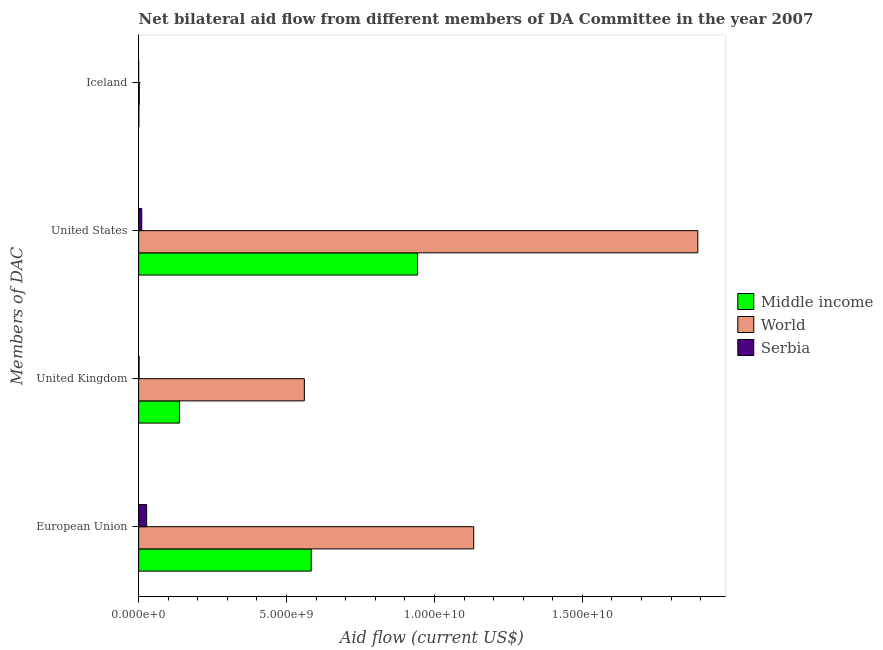How many different coloured bars are there?
Give a very brief answer. 3. How many groups of bars are there?
Give a very brief answer. 4. Are the number of bars per tick equal to the number of legend labels?
Your answer should be compact. Yes. Are the number of bars on each tick of the Y-axis equal?
Make the answer very short. Yes. How many bars are there on the 2nd tick from the top?
Offer a very short reply. 3. How many bars are there on the 4th tick from the bottom?
Provide a succinct answer. 3. What is the amount of aid given by iceland in Middle income?
Your answer should be very brief. 8.06e+06. Across all countries, what is the maximum amount of aid given by eu?
Make the answer very short. 1.13e+1. Across all countries, what is the minimum amount of aid given by us?
Your answer should be compact. 1.05e+08. In which country was the amount of aid given by us minimum?
Make the answer very short. Serbia. What is the total amount of aid given by iceland in the graph?
Give a very brief answer. 3.13e+07. What is the difference between the amount of aid given by us in World and that in Serbia?
Give a very brief answer. 1.88e+1. What is the difference between the amount of aid given by iceland in Middle income and the amount of aid given by uk in World?
Provide a succinct answer. -5.59e+09. What is the average amount of aid given by iceland per country?
Provide a short and direct response. 1.04e+07. What is the difference between the amount of aid given by us and amount of aid given by eu in Serbia?
Ensure brevity in your answer.  -1.66e+08. What is the ratio of the amount of aid given by us in Middle income to that in World?
Offer a terse response. 0.5. Is the amount of aid given by uk in World less than that in Serbia?
Give a very brief answer. No. Is the difference between the amount of aid given by us in World and Serbia greater than the difference between the amount of aid given by iceland in World and Serbia?
Your response must be concise. Yes. What is the difference between the highest and the second highest amount of aid given by eu?
Keep it short and to the point. 5.49e+09. What is the difference between the highest and the lowest amount of aid given by us?
Your response must be concise. 1.88e+1. What does the 1st bar from the top in United Kingdom represents?
Your answer should be very brief. Serbia. What does the 3rd bar from the bottom in European Union represents?
Provide a short and direct response. Serbia. How many bars are there?
Your response must be concise. 12. Are all the bars in the graph horizontal?
Make the answer very short. Yes. How many countries are there in the graph?
Keep it short and to the point. 3. Are the values on the major ticks of X-axis written in scientific E-notation?
Provide a succinct answer. Yes. How many legend labels are there?
Provide a succinct answer. 3. How are the legend labels stacked?
Keep it short and to the point. Vertical. What is the title of the graph?
Your answer should be very brief. Net bilateral aid flow from different members of DA Committee in the year 2007. What is the label or title of the Y-axis?
Ensure brevity in your answer.  Members of DAC. What is the Aid flow (current US$) of Middle income in European Union?
Ensure brevity in your answer.  5.83e+09. What is the Aid flow (current US$) in World in European Union?
Offer a terse response. 1.13e+1. What is the Aid flow (current US$) in Serbia in European Union?
Ensure brevity in your answer.  2.71e+08. What is the Aid flow (current US$) of Middle income in United Kingdom?
Offer a very short reply. 1.38e+09. What is the Aid flow (current US$) of World in United Kingdom?
Ensure brevity in your answer.  5.60e+09. What is the Aid flow (current US$) of Serbia in United Kingdom?
Give a very brief answer. 1.55e+07. What is the Aid flow (current US$) in Middle income in United States?
Your answer should be compact. 9.43e+09. What is the Aid flow (current US$) in World in United States?
Provide a succinct answer. 1.89e+1. What is the Aid flow (current US$) in Serbia in United States?
Offer a terse response. 1.05e+08. What is the Aid flow (current US$) of Middle income in Iceland?
Provide a short and direct response. 8.06e+06. What is the Aid flow (current US$) in World in Iceland?
Offer a very short reply. 2.30e+07. Across all Members of DAC, what is the maximum Aid flow (current US$) of Middle income?
Keep it short and to the point. 9.43e+09. Across all Members of DAC, what is the maximum Aid flow (current US$) of World?
Offer a terse response. 1.89e+1. Across all Members of DAC, what is the maximum Aid flow (current US$) in Serbia?
Provide a short and direct response. 2.71e+08. Across all Members of DAC, what is the minimum Aid flow (current US$) of Middle income?
Make the answer very short. 8.06e+06. Across all Members of DAC, what is the minimum Aid flow (current US$) in World?
Provide a short and direct response. 2.30e+07. Across all Members of DAC, what is the minimum Aid flow (current US$) in Serbia?
Your response must be concise. 2.20e+05. What is the total Aid flow (current US$) in Middle income in the graph?
Your answer should be compact. 1.66e+1. What is the total Aid flow (current US$) in World in the graph?
Ensure brevity in your answer.  3.59e+1. What is the total Aid flow (current US$) of Serbia in the graph?
Your answer should be very brief. 3.92e+08. What is the difference between the Aid flow (current US$) in Middle income in European Union and that in United Kingdom?
Give a very brief answer. 4.45e+09. What is the difference between the Aid flow (current US$) in World in European Union and that in United Kingdom?
Give a very brief answer. 5.72e+09. What is the difference between the Aid flow (current US$) in Serbia in European Union and that in United Kingdom?
Provide a short and direct response. 2.56e+08. What is the difference between the Aid flow (current US$) in Middle income in European Union and that in United States?
Provide a succinct answer. -3.59e+09. What is the difference between the Aid flow (current US$) in World in European Union and that in United States?
Make the answer very short. -7.58e+09. What is the difference between the Aid flow (current US$) of Serbia in European Union and that in United States?
Make the answer very short. 1.66e+08. What is the difference between the Aid flow (current US$) in Middle income in European Union and that in Iceland?
Your answer should be very brief. 5.83e+09. What is the difference between the Aid flow (current US$) in World in European Union and that in Iceland?
Offer a terse response. 1.13e+1. What is the difference between the Aid flow (current US$) in Serbia in European Union and that in Iceland?
Make the answer very short. 2.71e+08. What is the difference between the Aid flow (current US$) in Middle income in United Kingdom and that in United States?
Your answer should be compact. -8.04e+09. What is the difference between the Aid flow (current US$) of World in United Kingdom and that in United States?
Your response must be concise. -1.33e+1. What is the difference between the Aid flow (current US$) in Serbia in United Kingdom and that in United States?
Ensure brevity in your answer.  -8.96e+07. What is the difference between the Aid flow (current US$) of Middle income in United Kingdom and that in Iceland?
Your answer should be very brief. 1.37e+09. What is the difference between the Aid flow (current US$) of World in United Kingdom and that in Iceland?
Make the answer very short. 5.58e+09. What is the difference between the Aid flow (current US$) in Serbia in United Kingdom and that in Iceland?
Your response must be concise. 1.52e+07. What is the difference between the Aid flow (current US$) of Middle income in United States and that in Iceland?
Give a very brief answer. 9.42e+09. What is the difference between the Aid flow (current US$) in World in United States and that in Iceland?
Ensure brevity in your answer.  1.89e+1. What is the difference between the Aid flow (current US$) of Serbia in United States and that in Iceland?
Provide a short and direct response. 1.05e+08. What is the difference between the Aid flow (current US$) of Middle income in European Union and the Aid flow (current US$) of World in United Kingdom?
Ensure brevity in your answer.  2.33e+08. What is the difference between the Aid flow (current US$) in Middle income in European Union and the Aid flow (current US$) in Serbia in United Kingdom?
Your answer should be compact. 5.82e+09. What is the difference between the Aid flow (current US$) in World in European Union and the Aid flow (current US$) in Serbia in United Kingdom?
Provide a succinct answer. 1.13e+1. What is the difference between the Aid flow (current US$) in Middle income in European Union and the Aid flow (current US$) in World in United States?
Give a very brief answer. -1.31e+1. What is the difference between the Aid flow (current US$) in Middle income in European Union and the Aid flow (current US$) in Serbia in United States?
Offer a terse response. 5.73e+09. What is the difference between the Aid flow (current US$) of World in European Union and the Aid flow (current US$) of Serbia in United States?
Make the answer very short. 1.12e+1. What is the difference between the Aid flow (current US$) of Middle income in European Union and the Aid flow (current US$) of World in Iceland?
Your answer should be compact. 5.81e+09. What is the difference between the Aid flow (current US$) of Middle income in European Union and the Aid flow (current US$) of Serbia in Iceland?
Offer a very short reply. 5.83e+09. What is the difference between the Aid flow (current US$) in World in European Union and the Aid flow (current US$) in Serbia in Iceland?
Your answer should be compact. 1.13e+1. What is the difference between the Aid flow (current US$) in Middle income in United Kingdom and the Aid flow (current US$) in World in United States?
Give a very brief answer. -1.75e+1. What is the difference between the Aid flow (current US$) of Middle income in United Kingdom and the Aid flow (current US$) of Serbia in United States?
Provide a succinct answer. 1.28e+09. What is the difference between the Aid flow (current US$) of World in United Kingdom and the Aid flow (current US$) of Serbia in United States?
Provide a succinct answer. 5.50e+09. What is the difference between the Aid flow (current US$) of Middle income in United Kingdom and the Aid flow (current US$) of World in Iceland?
Keep it short and to the point. 1.36e+09. What is the difference between the Aid flow (current US$) of Middle income in United Kingdom and the Aid flow (current US$) of Serbia in Iceland?
Your answer should be very brief. 1.38e+09. What is the difference between the Aid flow (current US$) of World in United Kingdom and the Aid flow (current US$) of Serbia in Iceland?
Offer a very short reply. 5.60e+09. What is the difference between the Aid flow (current US$) in Middle income in United States and the Aid flow (current US$) in World in Iceland?
Your response must be concise. 9.40e+09. What is the difference between the Aid flow (current US$) in Middle income in United States and the Aid flow (current US$) in Serbia in Iceland?
Make the answer very short. 9.42e+09. What is the difference between the Aid flow (current US$) of World in United States and the Aid flow (current US$) of Serbia in Iceland?
Your response must be concise. 1.89e+1. What is the average Aid flow (current US$) in Middle income per Members of DAC?
Keep it short and to the point. 4.16e+09. What is the average Aid flow (current US$) in World per Members of DAC?
Offer a very short reply. 8.96e+09. What is the average Aid flow (current US$) in Serbia per Members of DAC?
Give a very brief answer. 9.80e+07. What is the difference between the Aid flow (current US$) in Middle income and Aid flow (current US$) in World in European Union?
Make the answer very short. -5.49e+09. What is the difference between the Aid flow (current US$) of Middle income and Aid flow (current US$) of Serbia in European Union?
Ensure brevity in your answer.  5.56e+09. What is the difference between the Aid flow (current US$) of World and Aid flow (current US$) of Serbia in European Union?
Your response must be concise. 1.11e+1. What is the difference between the Aid flow (current US$) in Middle income and Aid flow (current US$) in World in United Kingdom?
Your answer should be very brief. -4.22e+09. What is the difference between the Aid flow (current US$) of Middle income and Aid flow (current US$) of Serbia in United Kingdom?
Offer a terse response. 1.37e+09. What is the difference between the Aid flow (current US$) of World and Aid flow (current US$) of Serbia in United Kingdom?
Keep it short and to the point. 5.59e+09. What is the difference between the Aid flow (current US$) in Middle income and Aid flow (current US$) in World in United States?
Offer a terse response. -9.48e+09. What is the difference between the Aid flow (current US$) in Middle income and Aid flow (current US$) in Serbia in United States?
Provide a succinct answer. 9.32e+09. What is the difference between the Aid flow (current US$) of World and Aid flow (current US$) of Serbia in United States?
Your answer should be compact. 1.88e+1. What is the difference between the Aid flow (current US$) in Middle income and Aid flow (current US$) in World in Iceland?
Make the answer very short. -1.50e+07. What is the difference between the Aid flow (current US$) in Middle income and Aid flow (current US$) in Serbia in Iceland?
Provide a succinct answer. 7.84e+06. What is the difference between the Aid flow (current US$) of World and Aid flow (current US$) of Serbia in Iceland?
Your answer should be compact. 2.28e+07. What is the ratio of the Aid flow (current US$) of Middle income in European Union to that in United Kingdom?
Provide a short and direct response. 4.22. What is the ratio of the Aid flow (current US$) of World in European Union to that in United Kingdom?
Provide a succinct answer. 2.02. What is the ratio of the Aid flow (current US$) in Serbia in European Union to that in United Kingdom?
Offer a very short reply. 17.52. What is the ratio of the Aid flow (current US$) of Middle income in European Union to that in United States?
Keep it short and to the point. 0.62. What is the ratio of the Aid flow (current US$) in World in European Union to that in United States?
Ensure brevity in your answer.  0.6. What is the ratio of the Aid flow (current US$) in Serbia in European Union to that in United States?
Offer a very short reply. 2.58. What is the ratio of the Aid flow (current US$) of Middle income in European Union to that in Iceland?
Your answer should be very brief. 723.84. What is the ratio of the Aid flow (current US$) of World in European Union to that in Iceland?
Provide a succinct answer. 492.23. What is the ratio of the Aid flow (current US$) of Serbia in European Union to that in Iceland?
Offer a terse response. 1232.18. What is the ratio of the Aid flow (current US$) in Middle income in United Kingdom to that in United States?
Ensure brevity in your answer.  0.15. What is the ratio of the Aid flow (current US$) in World in United Kingdom to that in United States?
Offer a terse response. 0.3. What is the ratio of the Aid flow (current US$) in Serbia in United Kingdom to that in United States?
Provide a short and direct response. 0.15. What is the ratio of the Aid flow (current US$) of Middle income in United Kingdom to that in Iceland?
Offer a very short reply. 171.43. What is the ratio of the Aid flow (current US$) of World in United Kingdom to that in Iceland?
Keep it short and to the point. 243.44. What is the ratio of the Aid flow (current US$) of Serbia in United Kingdom to that in Iceland?
Provide a succinct answer. 70.32. What is the ratio of the Aid flow (current US$) of Middle income in United States to that in Iceland?
Give a very brief answer. 1169.37. What is the ratio of the Aid flow (current US$) of World in United States to that in Iceland?
Give a very brief answer. 821.43. What is the ratio of the Aid flow (current US$) in Serbia in United States to that in Iceland?
Give a very brief answer. 477.82. What is the difference between the highest and the second highest Aid flow (current US$) in Middle income?
Ensure brevity in your answer.  3.59e+09. What is the difference between the highest and the second highest Aid flow (current US$) of World?
Give a very brief answer. 7.58e+09. What is the difference between the highest and the second highest Aid flow (current US$) of Serbia?
Offer a terse response. 1.66e+08. What is the difference between the highest and the lowest Aid flow (current US$) of Middle income?
Make the answer very short. 9.42e+09. What is the difference between the highest and the lowest Aid flow (current US$) in World?
Provide a succinct answer. 1.89e+1. What is the difference between the highest and the lowest Aid flow (current US$) in Serbia?
Your answer should be very brief. 2.71e+08. 